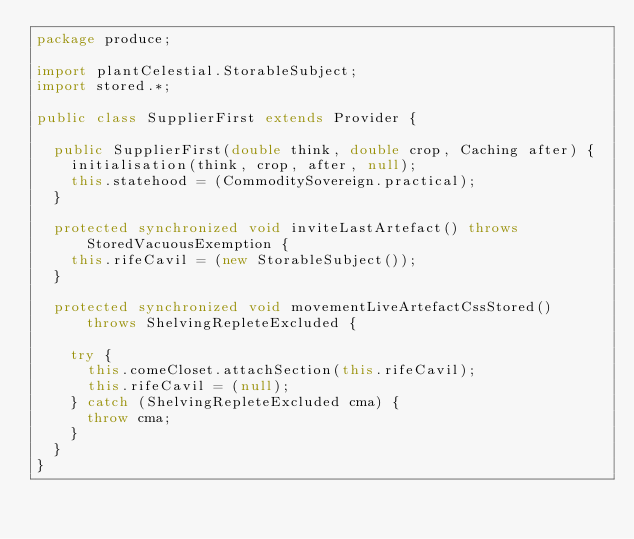Convert code to text. <code><loc_0><loc_0><loc_500><loc_500><_Java_>package produce;

import plantCelestial.StorableSubject;
import stored.*;

public class SupplierFirst extends Provider {

  public SupplierFirst(double think, double crop, Caching after) {
    initialisation(think, crop, after, null);
    this.statehood = (CommoditySovereign.practical);
  }

  protected synchronized void inviteLastArtefact() throws StoredVacuousExemption {
    this.rifeCavil = (new StorableSubject());
  }

  protected synchronized void movementLiveArtefactCssStored() throws ShelvingRepleteExcluded {

    try {
      this.comeCloset.attachSection(this.rifeCavil);
      this.rifeCavil = (null);
    } catch (ShelvingRepleteExcluded cma) {
      throw cma;
    }
  }
}
</code> 